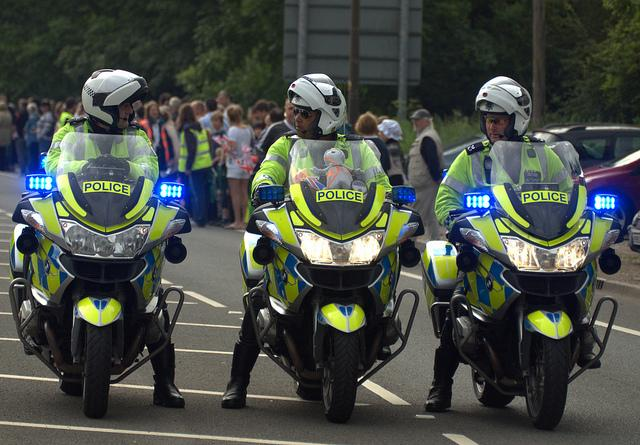Why are the bike riders wearing yellow? Please explain your reasoning. visibility. They want visibility. 